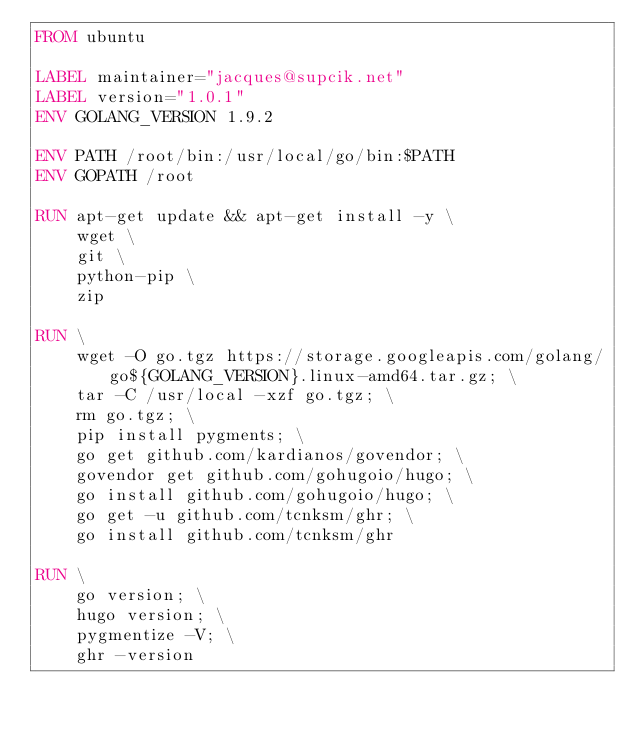Convert code to text. <code><loc_0><loc_0><loc_500><loc_500><_Dockerfile_>FROM ubuntu

LABEL maintainer="jacques@supcik.net"
LABEL version="1.0.1"
ENV GOLANG_VERSION 1.9.2

ENV PATH /root/bin:/usr/local/go/bin:$PATH
ENV GOPATH /root

RUN apt-get update && apt-get install -y \
    wget \
    git \
    python-pip \
    zip

RUN \
    wget -O go.tgz https://storage.googleapis.com/golang/go${GOLANG_VERSION}.linux-amd64.tar.gz; \
    tar -C /usr/local -xzf go.tgz; \
	rm go.tgz; \
    pip install pygments; \
    go get github.com/kardianos/govendor; \
    govendor get github.com/gohugoio/hugo; \
    go install github.com/gohugoio/hugo; \
    go get -u github.com/tcnksm/ghr; \
    go install github.com/tcnksm/ghr

RUN \
    go version; \
    hugo version; \
    pygmentize -V; \
    ghr -version
</code> 